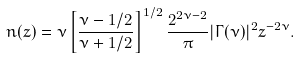<formula> <loc_0><loc_0><loc_500><loc_500>n ( z ) = \nu \left [ \frac { \nu - 1 / 2 } { \nu + 1 / 2 } \right ] ^ { 1 / 2 } \frac { 2 ^ { 2 \nu - 2 } } { \pi } | \Gamma ( \nu ) | ^ { 2 } z ^ { - 2 \nu } .</formula> 